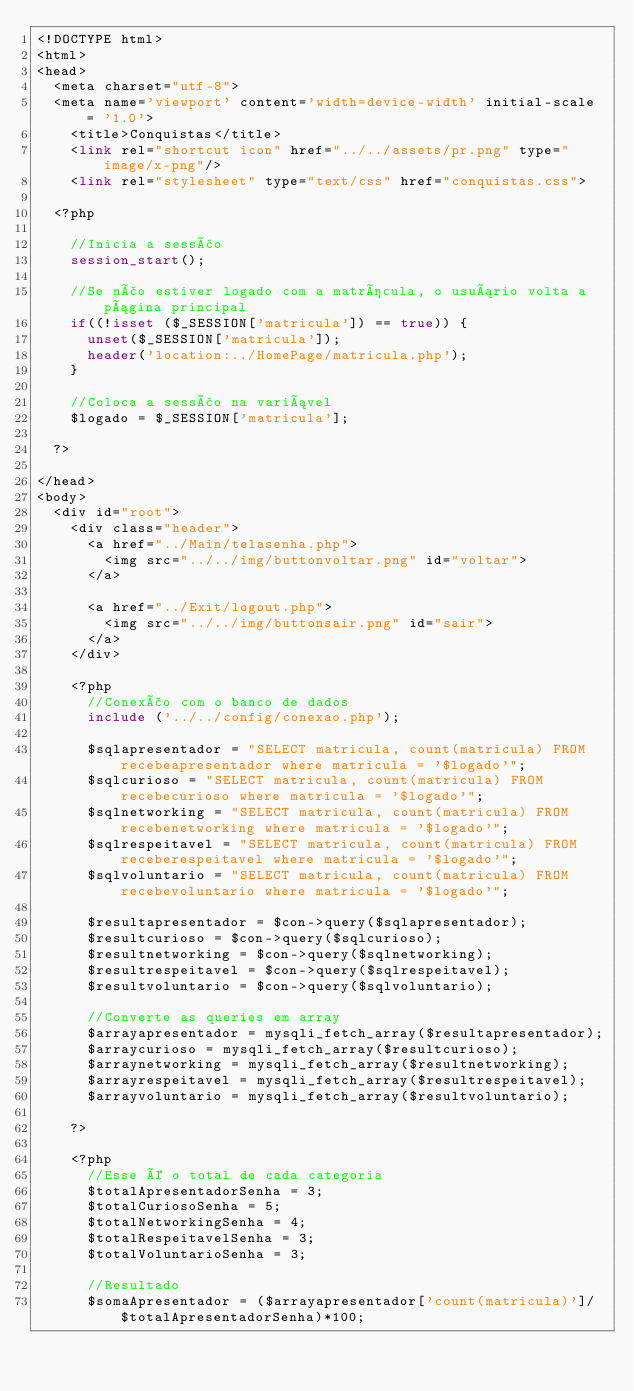Convert code to text. <code><loc_0><loc_0><loc_500><loc_500><_PHP_><!DOCTYPE html>
<html>
<head>
  <meta charset="utf-8">
  <meta name='viewport' content='width=device-width' initial-scale = '1.0'>
	<title>Conquistas</title>
	<link rel="shortcut icon" href="../../assets/pr.png" type="image/x-png"/>
	<link rel="stylesheet" type="text/css" href="conquistas.css">

  <?php

    //Inicia a sessão
    session_start();

    //Se não estiver logado com a matrícula, o usuário volta a página principal
    if((!isset ($_SESSION['matricula']) == true)) {
      unset($_SESSION['matricula']);
      header('location:../HomePage/matricula.php');
    }

    //Coloca a sessão na variável
    $logado = $_SESSION['matricula'];

  ?>

</head>
<body>
  <div id="root">
    <div class="header">
      <a href="../Main/telasenha.php">
        <img src="../../img/buttonvoltar.png" id="voltar">
      </a>

      <a href="../Exit/logout.php">
        <img src="../../img/buttonsair.png" id="sair">
      </a>
    </div>

    <?php
      //Conexão com o banco de dados
      include ('../../config/conexao.php');
      
      $sqlapresentador = "SELECT matricula, count(matricula) FROM recebeapresentador where matricula = '$logado'";
      $sqlcurioso = "SELECT matricula, count(matricula) FROM recebecurioso where matricula = '$logado'"; 
      $sqlnetworking = "SELECT matricula, count(matricula) FROM recebenetworking where matricula = '$logado'";
      $sqlrespeitavel = "SELECT matricula, count(matricula) FROM receberespeitavel where matricula = '$logado'";
      $sqlvoluntario = "SELECT matricula, count(matricula) FROM recebevoluntario where matricula = '$logado'";

      $resultapresentador = $con->query($sqlapresentador);
      $resultcurioso = $con->query($sqlcurioso);
      $resultnetworking = $con->query($sqlnetworking);
      $resultrespeitavel = $con->query($sqlrespeitavel);
      $resultvoluntario = $con->query($sqlvoluntario);
      
      //Converte as queries em array
      $arrayapresentador = mysqli_fetch_array($resultapresentador);
      $arraycurioso = mysqli_fetch_array($resultcurioso);
      $arraynetworking = mysqli_fetch_array($resultnetworking);
      $arrayrespeitavel = mysqli_fetch_array($resultrespeitavel);
      $arrayvoluntario = mysqli_fetch_array($resultvoluntario);
      
    ?>

    <?php
      //Esse é o total de cada categoria
      $totalApresentadorSenha = 3;
      $totalCuriosoSenha = 5;
      $totalNetworkingSenha = 4;
      $totalRespeitavelSenha = 3;
      $totalVoluntarioSenha = 3;

      //Resultado
      $somaApresentador = ($arrayapresentador['count(matricula)']/$totalApresentadorSenha)*100;</code> 